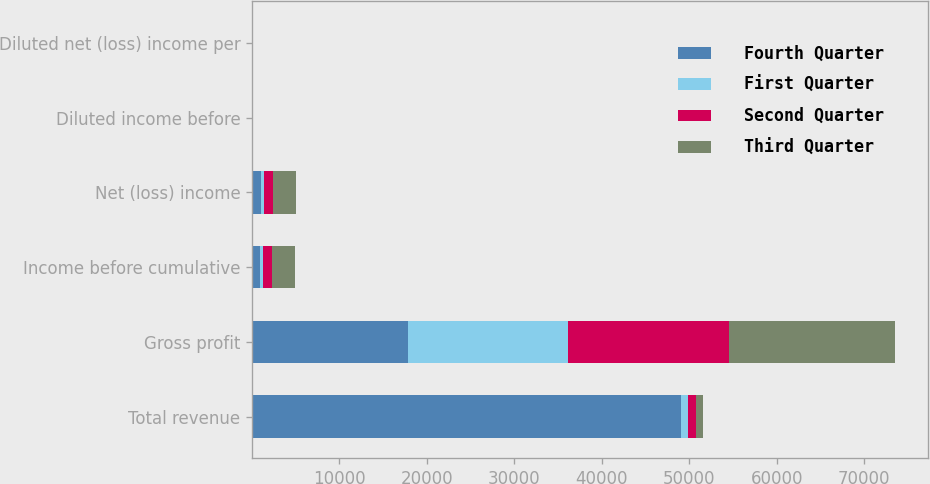Convert chart. <chart><loc_0><loc_0><loc_500><loc_500><stacked_bar_chart><ecel><fcel>Total revenue<fcel>Gross profit<fcel>Income before cumulative<fcel>Net (loss) income<fcel>Diluted income before<fcel>Diluted net (loss) income per<nl><fcel>Fourth Quarter<fcel>49002<fcel>17795<fcel>874<fcel>1081<fcel>0.05<fcel>0.06<nl><fcel>First Quarter<fcel>874<fcel>18312<fcel>344<fcel>344<fcel>0.2<fcel>0.02<nl><fcel>Second Quarter<fcel>874<fcel>18480<fcel>1049<fcel>1019<fcel>0.05<fcel>0.05<nl><fcel>Third Quarter<fcel>874<fcel>18993<fcel>2599<fcel>2599<fcel>0.13<fcel>0.13<nl></chart> 